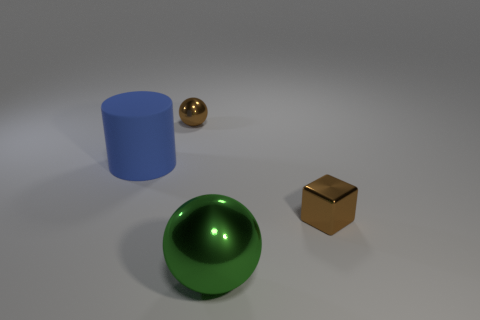Add 4 large yellow metallic objects. How many objects exist? 8 Subtract all brown balls. How many balls are left? 1 Subtract 1 cylinders. How many cylinders are left? 0 Subtract all purple cylinders. Subtract all purple blocks. How many cylinders are left? 1 Subtract all purple cylinders. How many brown spheres are left? 1 Subtract all large balls. Subtract all small metal objects. How many objects are left? 1 Add 1 big blue cylinders. How many big blue cylinders are left? 2 Add 3 large metallic spheres. How many large metallic spheres exist? 4 Subtract 0 red blocks. How many objects are left? 4 Subtract all cubes. How many objects are left? 3 